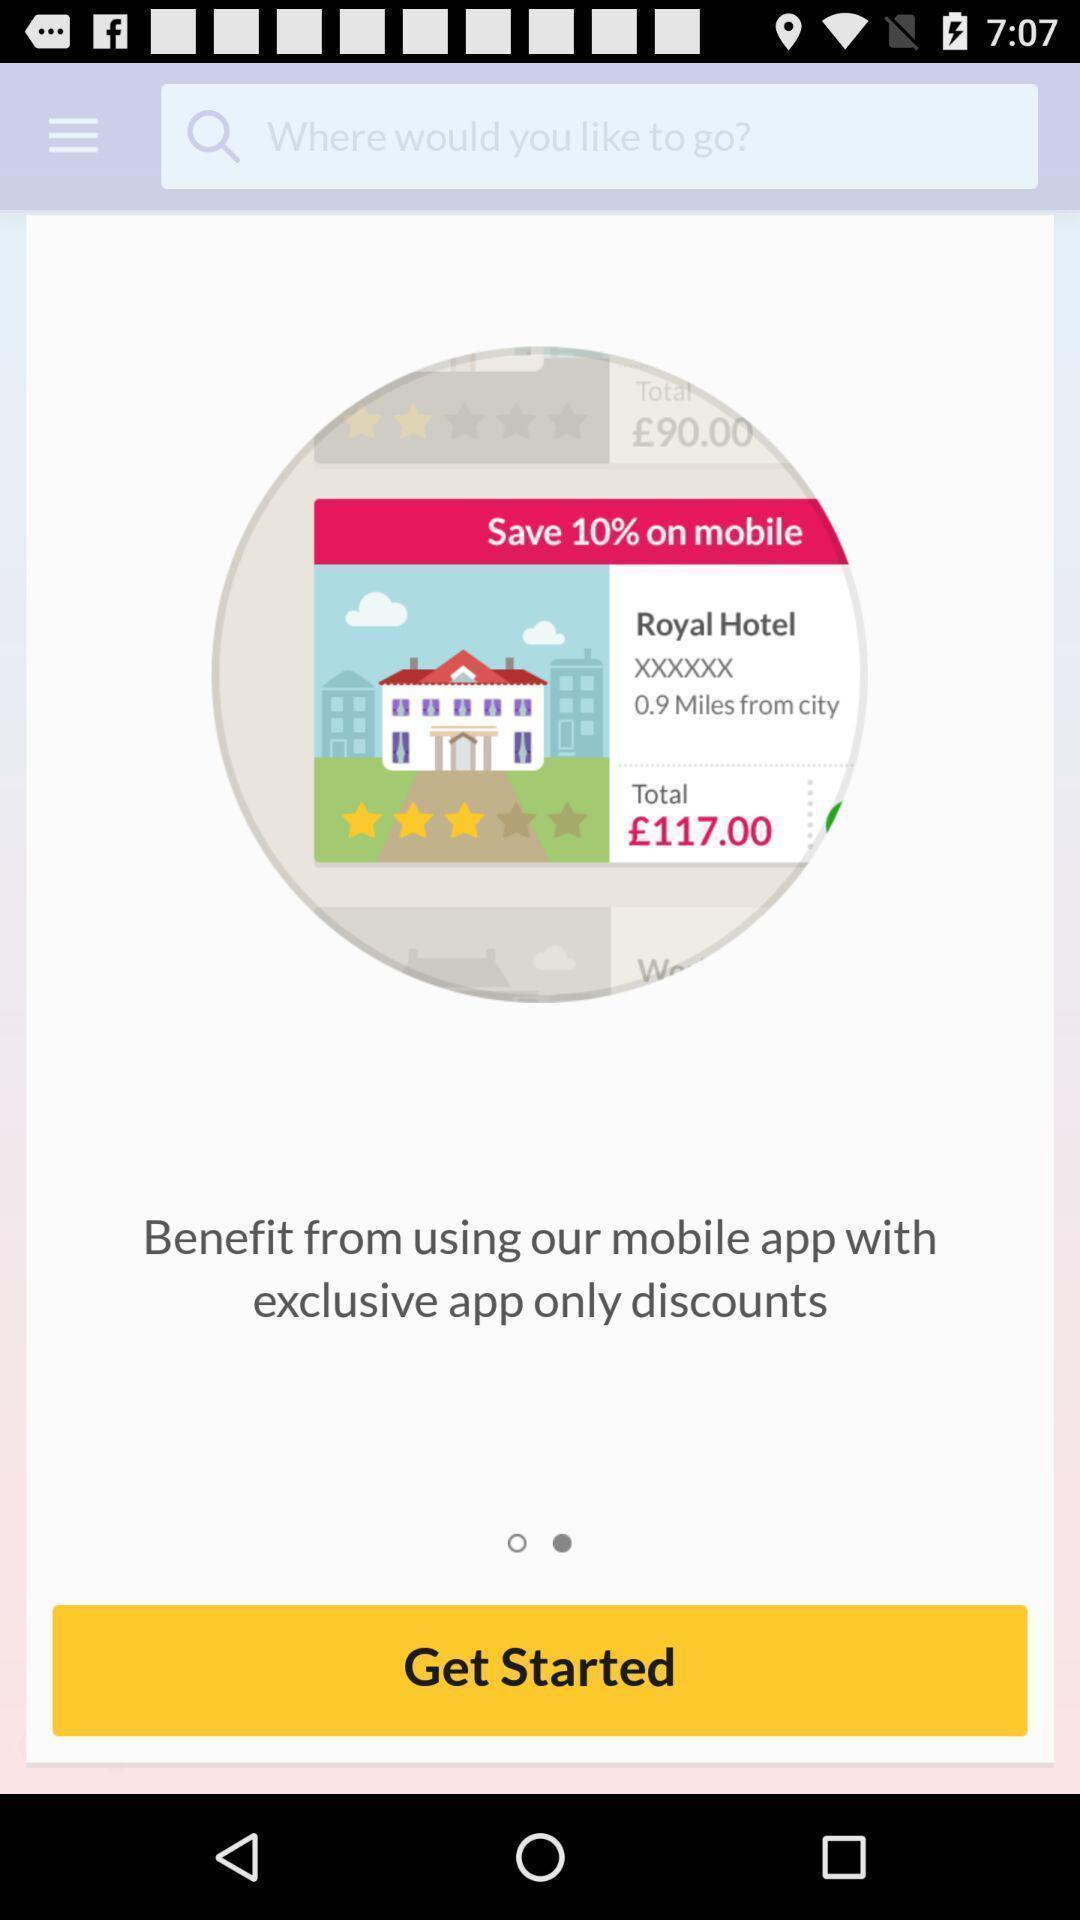Tell me about the visual elements in this screen capture. Welcome page. 